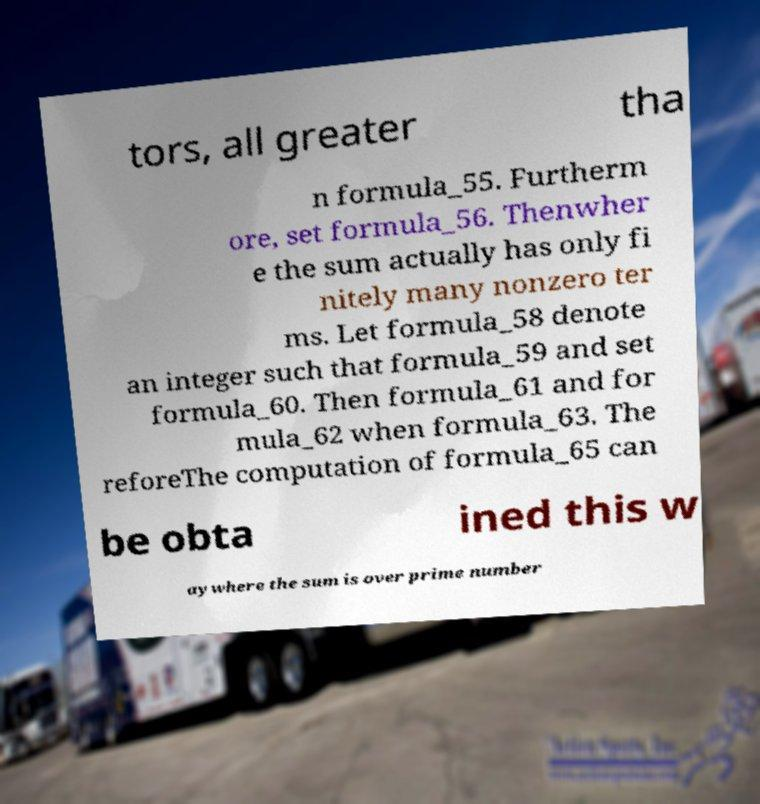Please read and relay the text visible in this image. What does it say? tors, all greater tha n formula_55. Furtherm ore, set formula_56. Thenwher e the sum actually has only fi nitely many nonzero ter ms. Let formula_58 denote an integer such that formula_59 and set formula_60. Then formula_61 and for mula_62 when formula_63. The reforeThe computation of formula_65 can be obta ined this w aywhere the sum is over prime number 